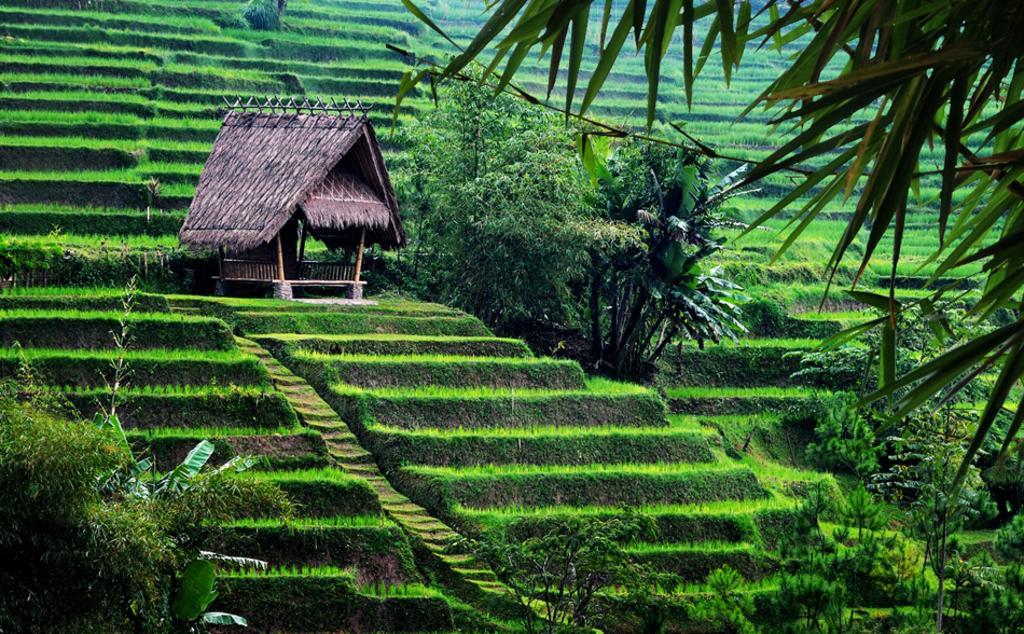Describe this image in one or two sentences. In the center of the image there is a hut. At the bottom of the image we can see trees and plants. In the background we can see trees and plants. 